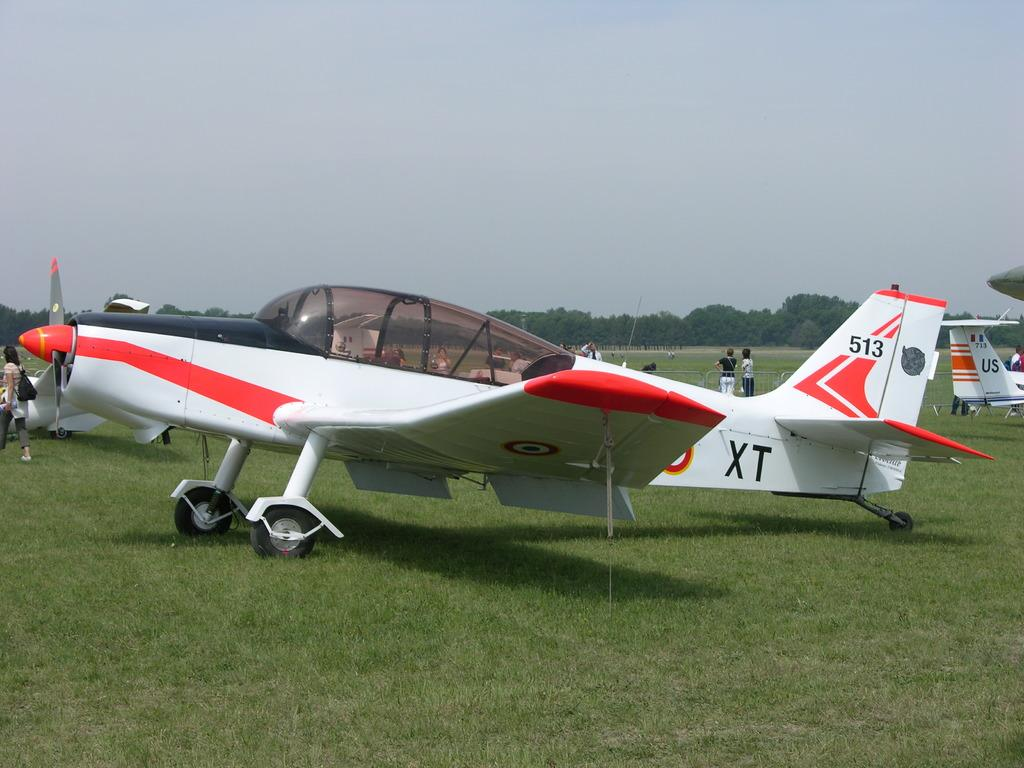Provide a one-sentence caption for the provided image. A small craft airplane bearing the number 513 on the tail and the letters XT on the fuselage is parked on an airfield. 